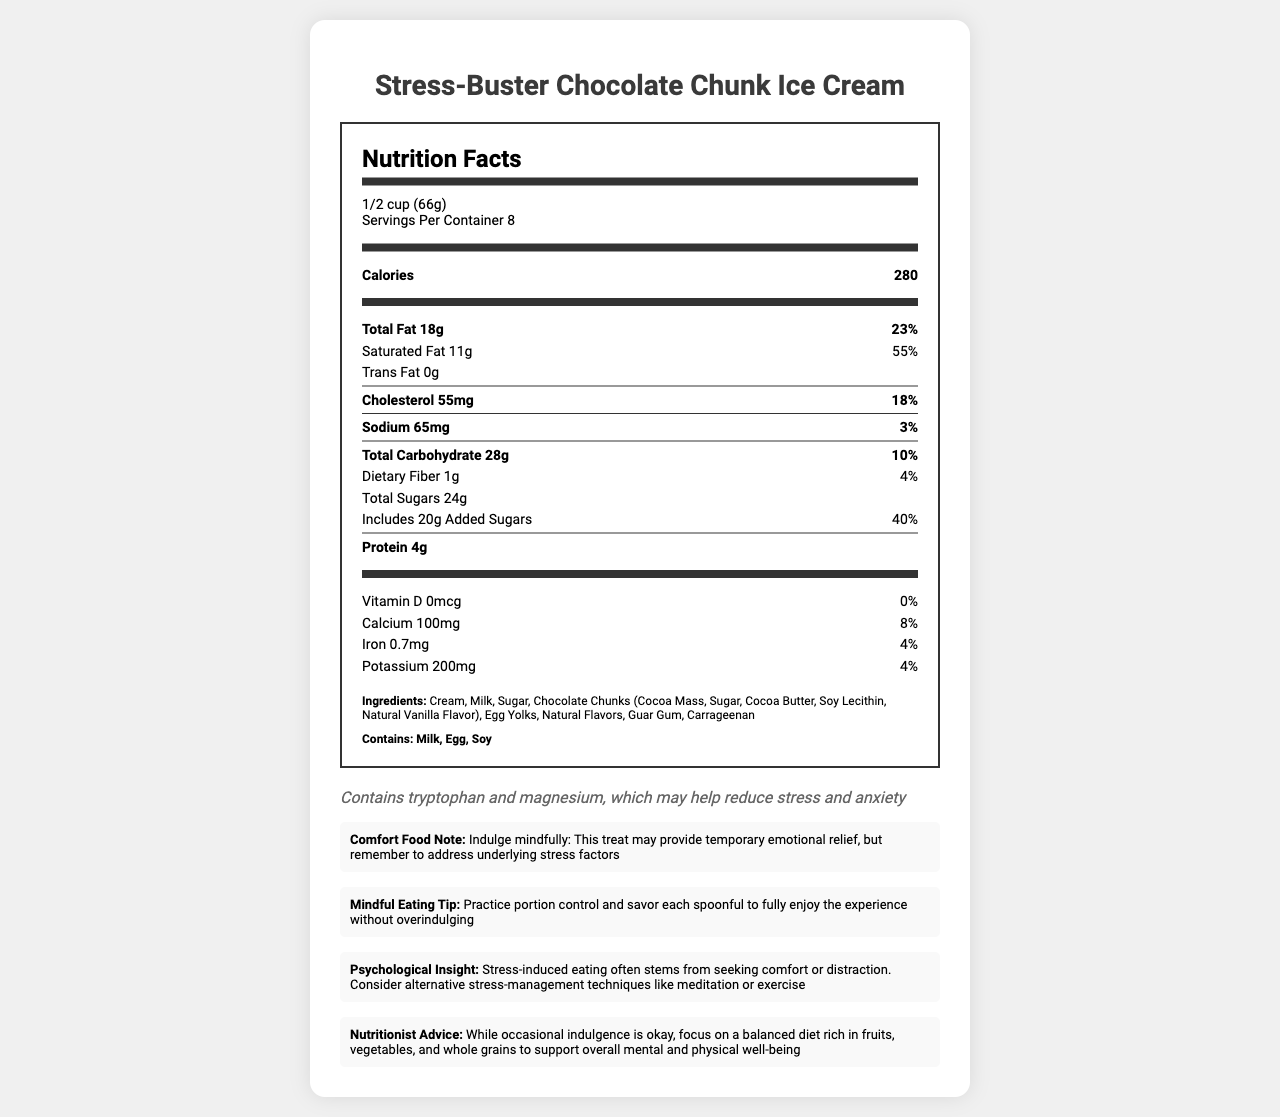what is the serving size? The serving size is listed at the beginning of the nutrition facts label as "1/2 cup (66g)".
Answer: 1/2 cup (66g) how many calories are in one serving? The calories per serving are displayed in a bold font right after the serving size information.
Answer: 280 what is the percentage of daily value for saturated fat in one serving? The percentage for saturated fat is shown next to the amount of saturated fat listed as "11g" with the daily value percentage of "55%".
Answer: 55% what is the total amount of added sugars in one serving? The document lists the total sugars as 24g and specifies that 20g of this is added sugars.
Answer: 20g which nutrients are present in amounts providing 4% of the daily value? A. Dietary Fiber and Iron B. Calcium and Potassium C. Sodium and Protein Dietary Fiber and Iron both show 4% in the daily value column.
Answer: A. Dietary Fiber and Iron what are the main ingredients in the product? The ingredient list mentions these items, summarizing them together as the main components.
Answer: Cream, Milk, Sugar, Chocolate Chunks, Egg Yolks, Natural Flavors, Guar Gum, Carrageenan does the product contain allergens? Allergens are explicitly listed in the "Contains" section including Milk, Egg, and Soy.
Answer: Yes what are two benefits mentioned in the document that the product claims to offer for stress relief? The document states under the stress-relief section that the product contains tryptophan and magnesium, which may help reduce stress and anxiety.
Answer: Contains tryptophan and magnesium summarize the main idea of the document. The summary captures the overall structure and key points covered by the document, giving an overview of the nutritional information, added benefits, and eating advice.
Answer: The document provides nutritional information for Stress-Buster Chocolate Chunk Ice Cream, including serving size, calories, fats, carbohydrates, and proteins, alongside ingredients and allergens. It discusses the potential stress-relief benefits of the product, notes about mindful eating, and offers psychological insights about stress-induced eating. how much calcium is in one serving, and what percentage of the daily value does this represent? The nutrition label shows that each serving contains 100mg of calcium, which represents 8% of the daily value.
Answer: 100mg (8%) what is the cholesterol content per serving? A. 18mg B. 55mg C. 65mg The cholesterol content per serving is listed as "55mg" with a daily value percentage of 18%.
Answer: B. 55mg is the product free from trans fat? The document shows "Trans Fat 0g", indicating that there are no trans fats present in each serving.
Answer: Yes how does the document advise people to eat this comfort food mindfully? The mindful eating tip advises practicing portion control and enjoying each spoonful to avoid overindulging.
Answer: Practice portion control and savor each spoonful what alternative strategies for managing stress does the document suggest? The psychological insight section discusses stress-induced eating and recommends alternatives like meditation or exercise.
Answer: Meditation or exercise what is the total carbohydrate content, including dietary fiber and sugars? The total carbohydrate amount is explicitly listed as 28g, separated into dietary fiber and total sugars within that amount.
Answer: 28g what is the total amount of protein in one serving? The document shows "Protein 4g", indicating the protein content per serving.
Answer: 4g what percentage of the daily value of sodium does one serving provide? The daily value percentage for sodium is given as 3%.
Answer: 3% is there any information about whether the product is gluten-free? The document does not contain any mention of gluten or whether the product is gluten-free, so this cannot be concluded from the available details.
Answer: Not enough information 